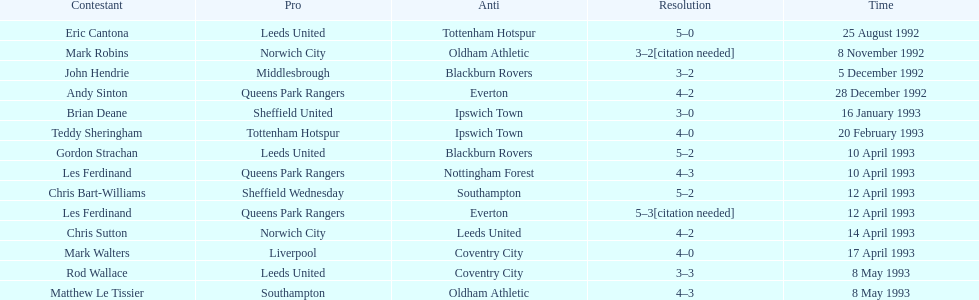Name the only player from france. Eric Cantona. 